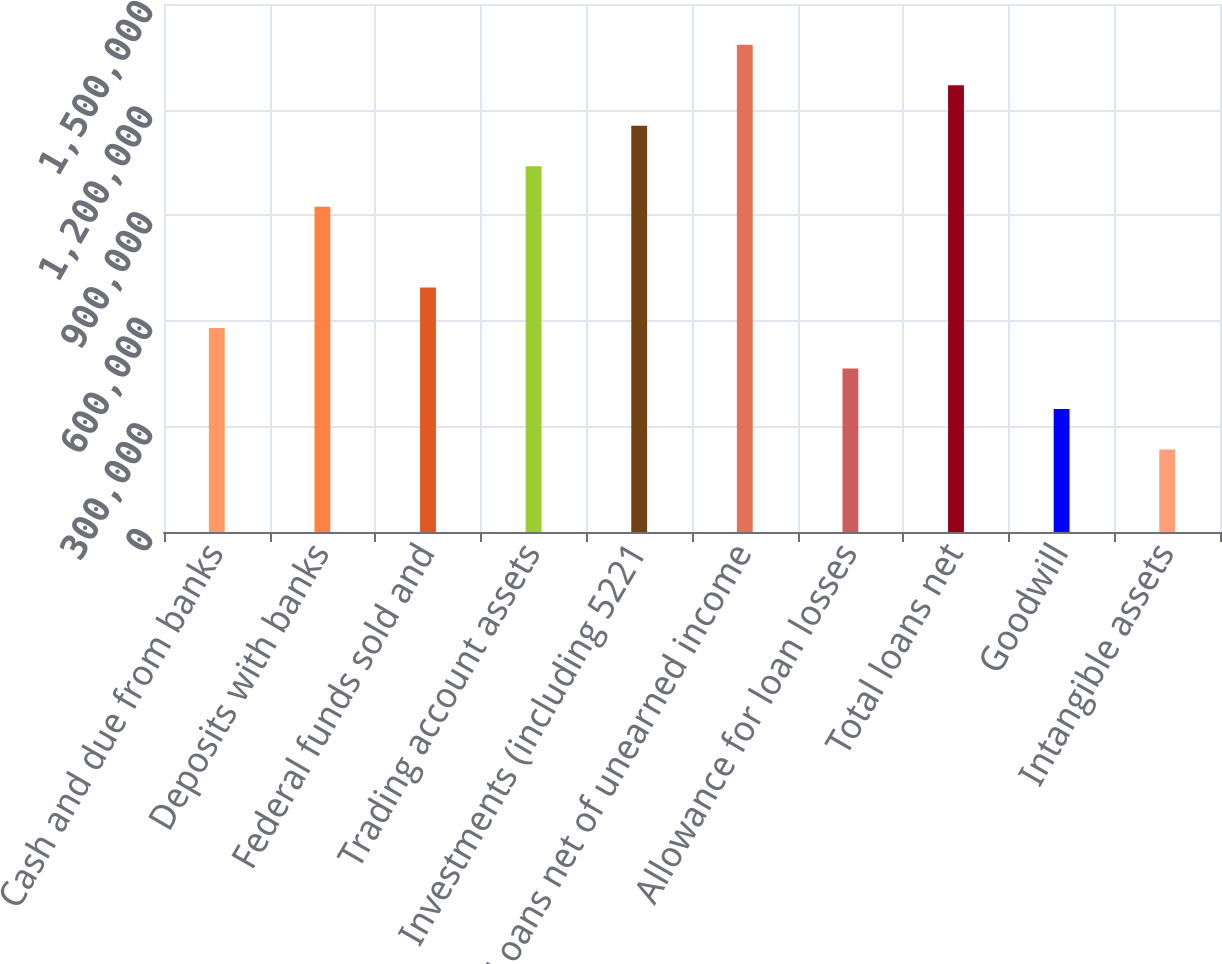Convert chart. <chart><loc_0><loc_0><loc_500><loc_500><bar_chart><fcel>Cash and due from banks<fcel>Deposits with banks<fcel>Federal funds sold and<fcel>Trading account assets<fcel>Investments (including 5221<fcel>Loans net of unearned income<fcel>Allowance for loan losses<fcel>Total loans net<fcel>Goodwill<fcel>Intangible assets<nl><fcel>579342<fcel>924313<fcel>694333<fcel>1.0393e+06<fcel>1.15429e+06<fcel>1.38427e+06<fcel>464352<fcel>1.26928e+06<fcel>349362<fcel>234372<nl></chart> 